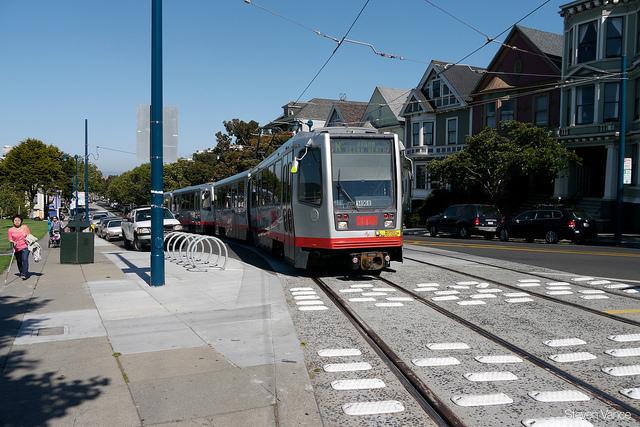What is pictured on the tracks?
Answer briefly. Train. What color is the signpost?
Answer briefly. Blue. What color is front of train?
Concise answer only. Gray. What kind of buildings are behind the train?
Quick response, please. Houses. What color is the front of the train?
Concise answer only. Gray. Where is the trolley getting power?
Quick response, please. Power line. 